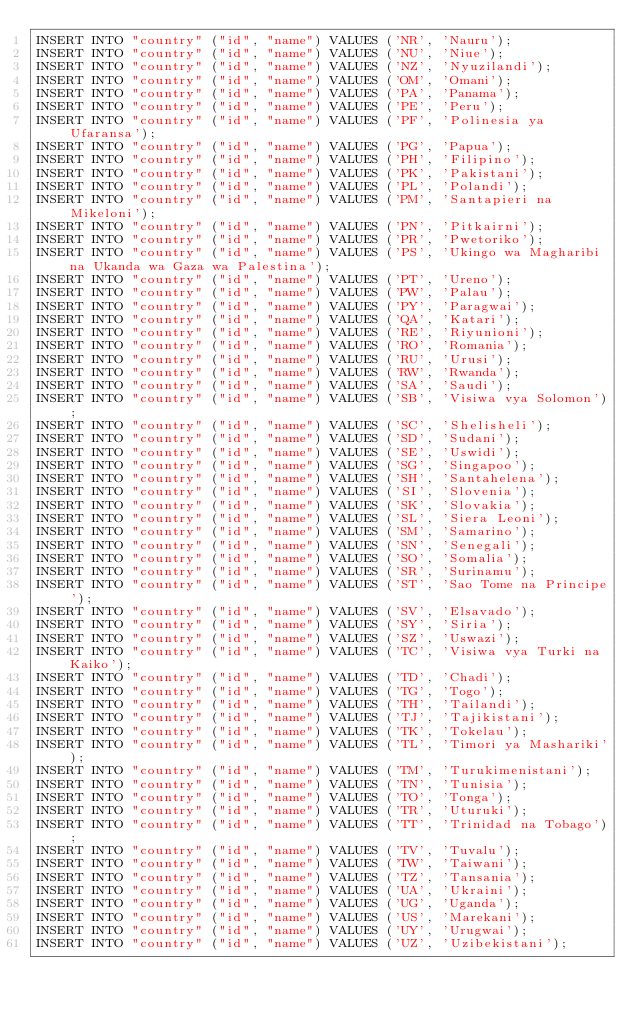<code> <loc_0><loc_0><loc_500><loc_500><_SQL_>INSERT INTO "country" ("id", "name") VALUES ('NR', 'Nauru');
INSERT INTO "country" ("id", "name") VALUES ('NU', 'Niue');
INSERT INTO "country" ("id", "name") VALUES ('NZ', 'Nyuzilandi');
INSERT INTO "country" ("id", "name") VALUES ('OM', 'Omani');
INSERT INTO "country" ("id", "name") VALUES ('PA', 'Panama');
INSERT INTO "country" ("id", "name") VALUES ('PE', 'Peru');
INSERT INTO "country" ("id", "name") VALUES ('PF', 'Polinesia ya Ufaransa');
INSERT INTO "country" ("id", "name") VALUES ('PG', 'Papua');
INSERT INTO "country" ("id", "name") VALUES ('PH', 'Filipino');
INSERT INTO "country" ("id", "name") VALUES ('PK', 'Pakistani');
INSERT INTO "country" ("id", "name") VALUES ('PL', 'Polandi');
INSERT INTO "country" ("id", "name") VALUES ('PM', 'Santapieri na Mikeloni');
INSERT INTO "country" ("id", "name") VALUES ('PN', 'Pitkairni');
INSERT INTO "country" ("id", "name") VALUES ('PR', 'Pwetoriko');
INSERT INTO "country" ("id", "name") VALUES ('PS', 'Ukingo wa Magharibi na Ukanda wa Gaza wa Palestina');
INSERT INTO "country" ("id", "name") VALUES ('PT', 'Ureno');
INSERT INTO "country" ("id", "name") VALUES ('PW', 'Palau');
INSERT INTO "country" ("id", "name") VALUES ('PY', 'Paragwai');
INSERT INTO "country" ("id", "name") VALUES ('QA', 'Katari');
INSERT INTO "country" ("id", "name") VALUES ('RE', 'Riyunioni');
INSERT INTO "country" ("id", "name") VALUES ('RO', 'Romania');
INSERT INTO "country" ("id", "name") VALUES ('RU', 'Urusi');
INSERT INTO "country" ("id", "name") VALUES ('RW', 'Rwanda');
INSERT INTO "country" ("id", "name") VALUES ('SA', 'Saudi');
INSERT INTO "country" ("id", "name") VALUES ('SB', 'Visiwa vya Solomon');
INSERT INTO "country" ("id", "name") VALUES ('SC', 'Shelisheli');
INSERT INTO "country" ("id", "name") VALUES ('SD', 'Sudani');
INSERT INTO "country" ("id", "name") VALUES ('SE', 'Uswidi');
INSERT INTO "country" ("id", "name") VALUES ('SG', 'Singapoo');
INSERT INTO "country" ("id", "name") VALUES ('SH', 'Santahelena');
INSERT INTO "country" ("id", "name") VALUES ('SI', 'Slovenia');
INSERT INTO "country" ("id", "name") VALUES ('SK', 'Slovakia');
INSERT INTO "country" ("id", "name") VALUES ('SL', 'Siera Leoni');
INSERT INTO "country" ("id", "name") VALUES ('SM', 'Samarino');
INSERT INTO "country" ("id", "name") VALUES ('SN', 'Senegali');
INSERT INTO "country" ("id", "name") VALUES ('SO', 'Somalia');
INSERT INTO "country" ("id", "name") VALUES ('SR', 'Surinamu');
INSERT INTO "country" ("id", "name") VALUES ('ST', 'Sao Tome na Principe');
INSERT INTO "country" ("id", "name") VALUES ('SV', 'Elsavado');
INSERT INTO "country" ("id", "name") VALUES ('SY', 'Siria');
INSERT INTO "country" ("id", "name") VALUES ('SZ', 'Uswazi');
INSERT INTO "country" ("id", "name") VALUES ('TC', 'Visiwa vya Turki na Kaiko');
INSERT INTO "country" ("id", "name") VALUES ('TD', 'Chadi');
INSERT INTO "country" ("id", "name") VALUES ('TG', 'Togo');
INSERT INTO "country" ("id", "name") VALUES ('TH', 'Tailandi');
INSERT INTO "country" ("id", "name") VALUES ('TJ', 'Tajikistani');
INSERT INTO "country" ("id", "name") VALUES ('TK', 'Tokelau');
INSERT INTO "country" ("id", "name") VALUES ('TL', 'Timori ya Mashariki');
INSERT INTO "country" ("id", "name") VALUES ('TM', 'Turukimenistani');
INSERT INTO "country" ("id", "name") VALUES ('TN', 'Tunisia');
INSERT INTO "country" ("id", "name") VALUES ('TO', 'Tonga');
INSERT INTO "country" ("id", "name") VALUES ('TR', 'Uturuki');
INSERT INTO "country" ("id", "name") VALUES ('TT', 'Trinidad na Tobago');
INSERT INTO "country" ("id", "name") VALUES ('TV', 'Tuvalu');
INSERT INTO "country" ("id", "name") VALUES ('TW', 'Taiwani');
INSERT INTO "country" ("id", "name") VALUES ('TZ', 'Tansania');
INSERT INTO "country" ("id", "name") VALUES ('UA', 'Ukraini');
INSERT INTO "country" ("id", "name") VALUES ('UG', 'Uganda');
INSERT INTO "country" ("id", "name") VALUES ('US', 'Marekani');
INSERT INTO "country" ("id", "name") VALUES ('UY', 'Urugwai');
INSERT INTO "country" ("id", "name") VALUES ('UZ', 'Uzibekistani');</code> 